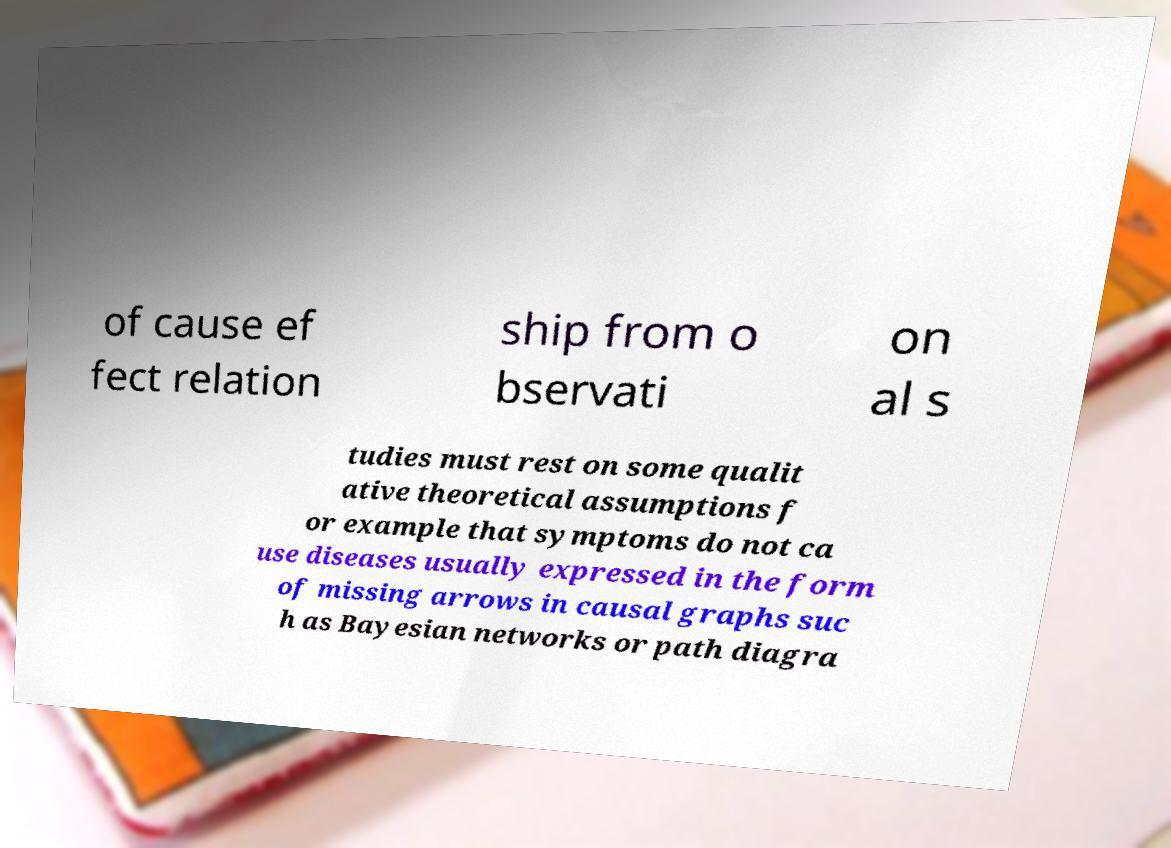Can you read and provide the text displayed in the image?This photo seems to have some interesting text. Can you extract and type it out for me? of cause ef fect relation ship from o bservati on al s tudies must rest on some qualit ative theoretical assumptions f or example that symptoms do not ca use diseases usually expressed in the form of missing arrows in causal graphs suc h as Bayesian networks or path diagra 